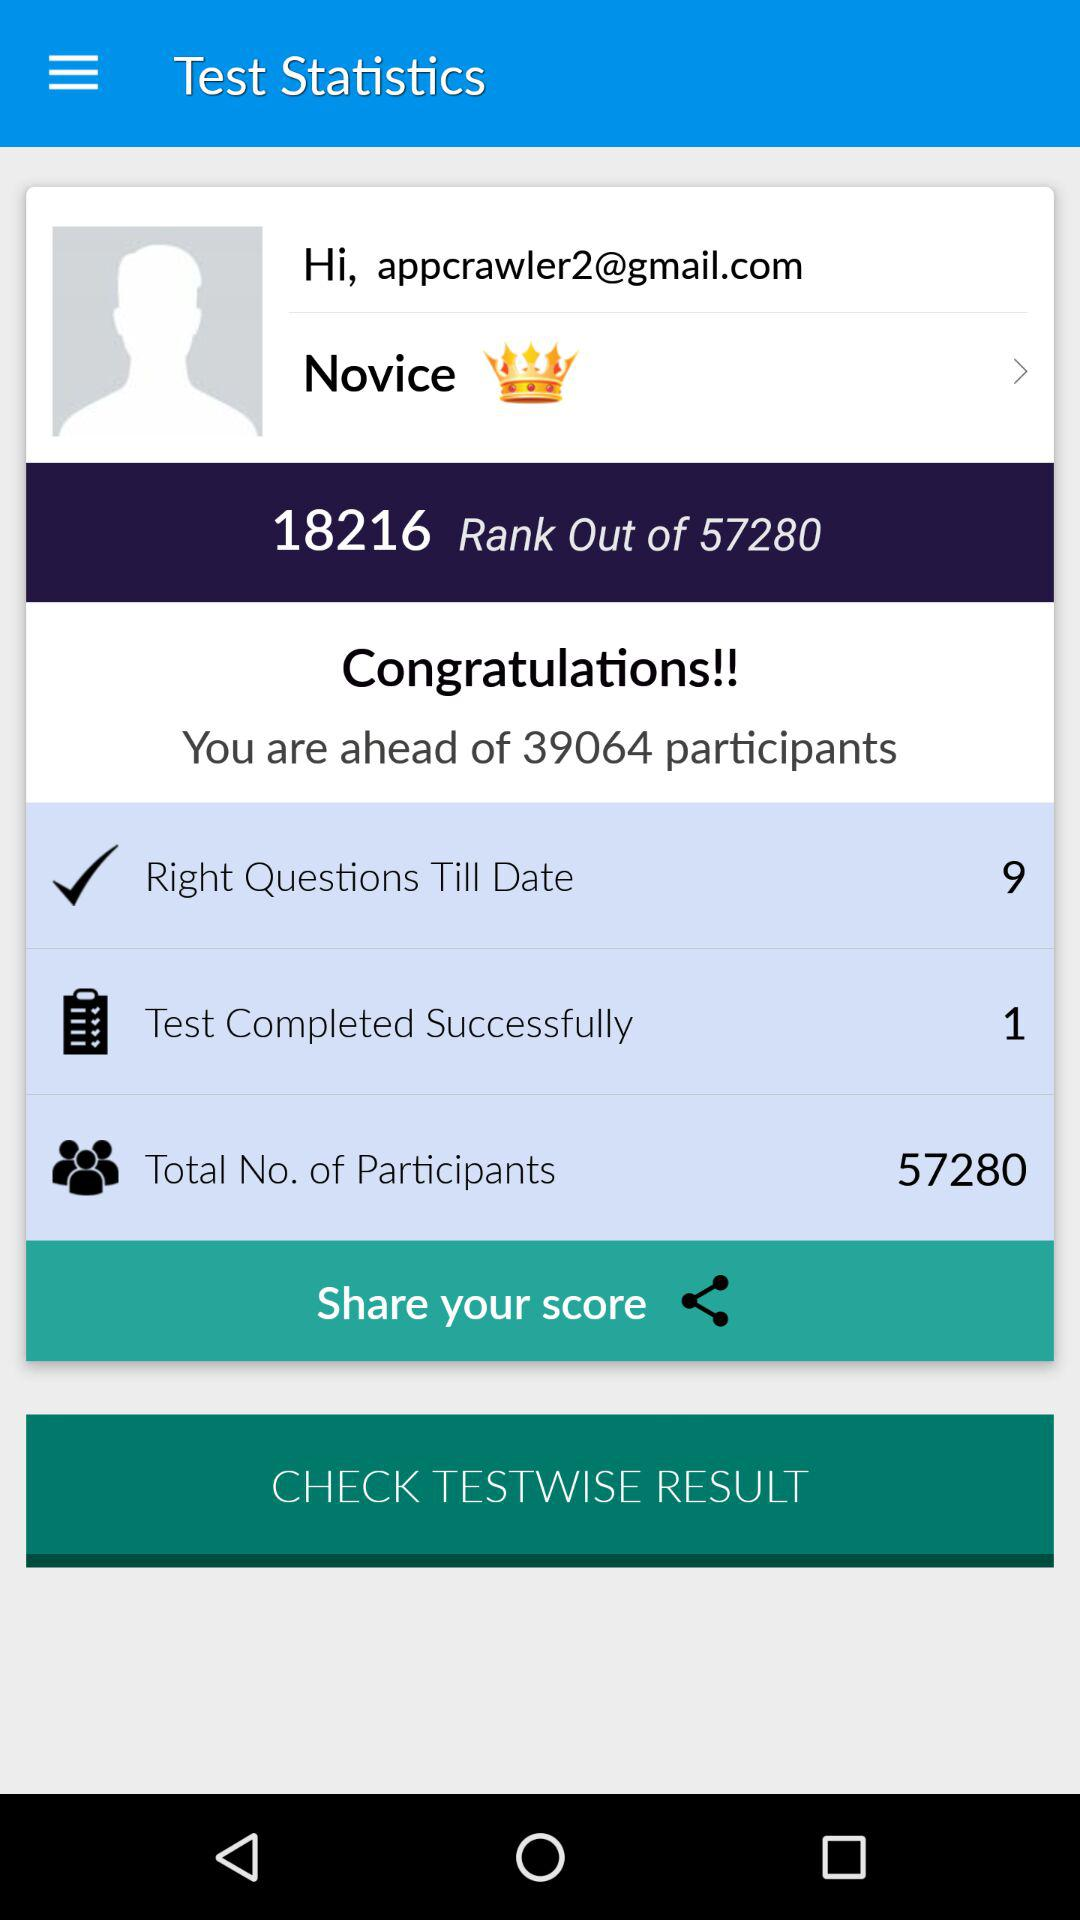What is the total number of participants? The total number of participants is 57280. 